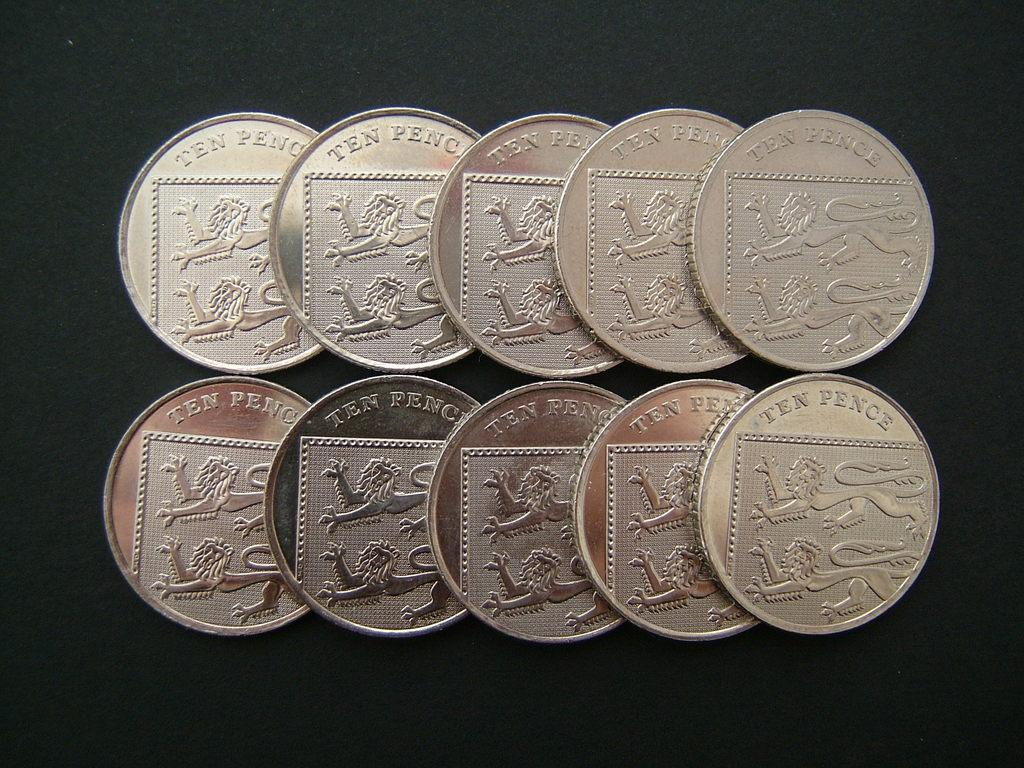<image>
Write a terse but informative summary of the picture. Several coins value at  ten pence rest upon a table together. 